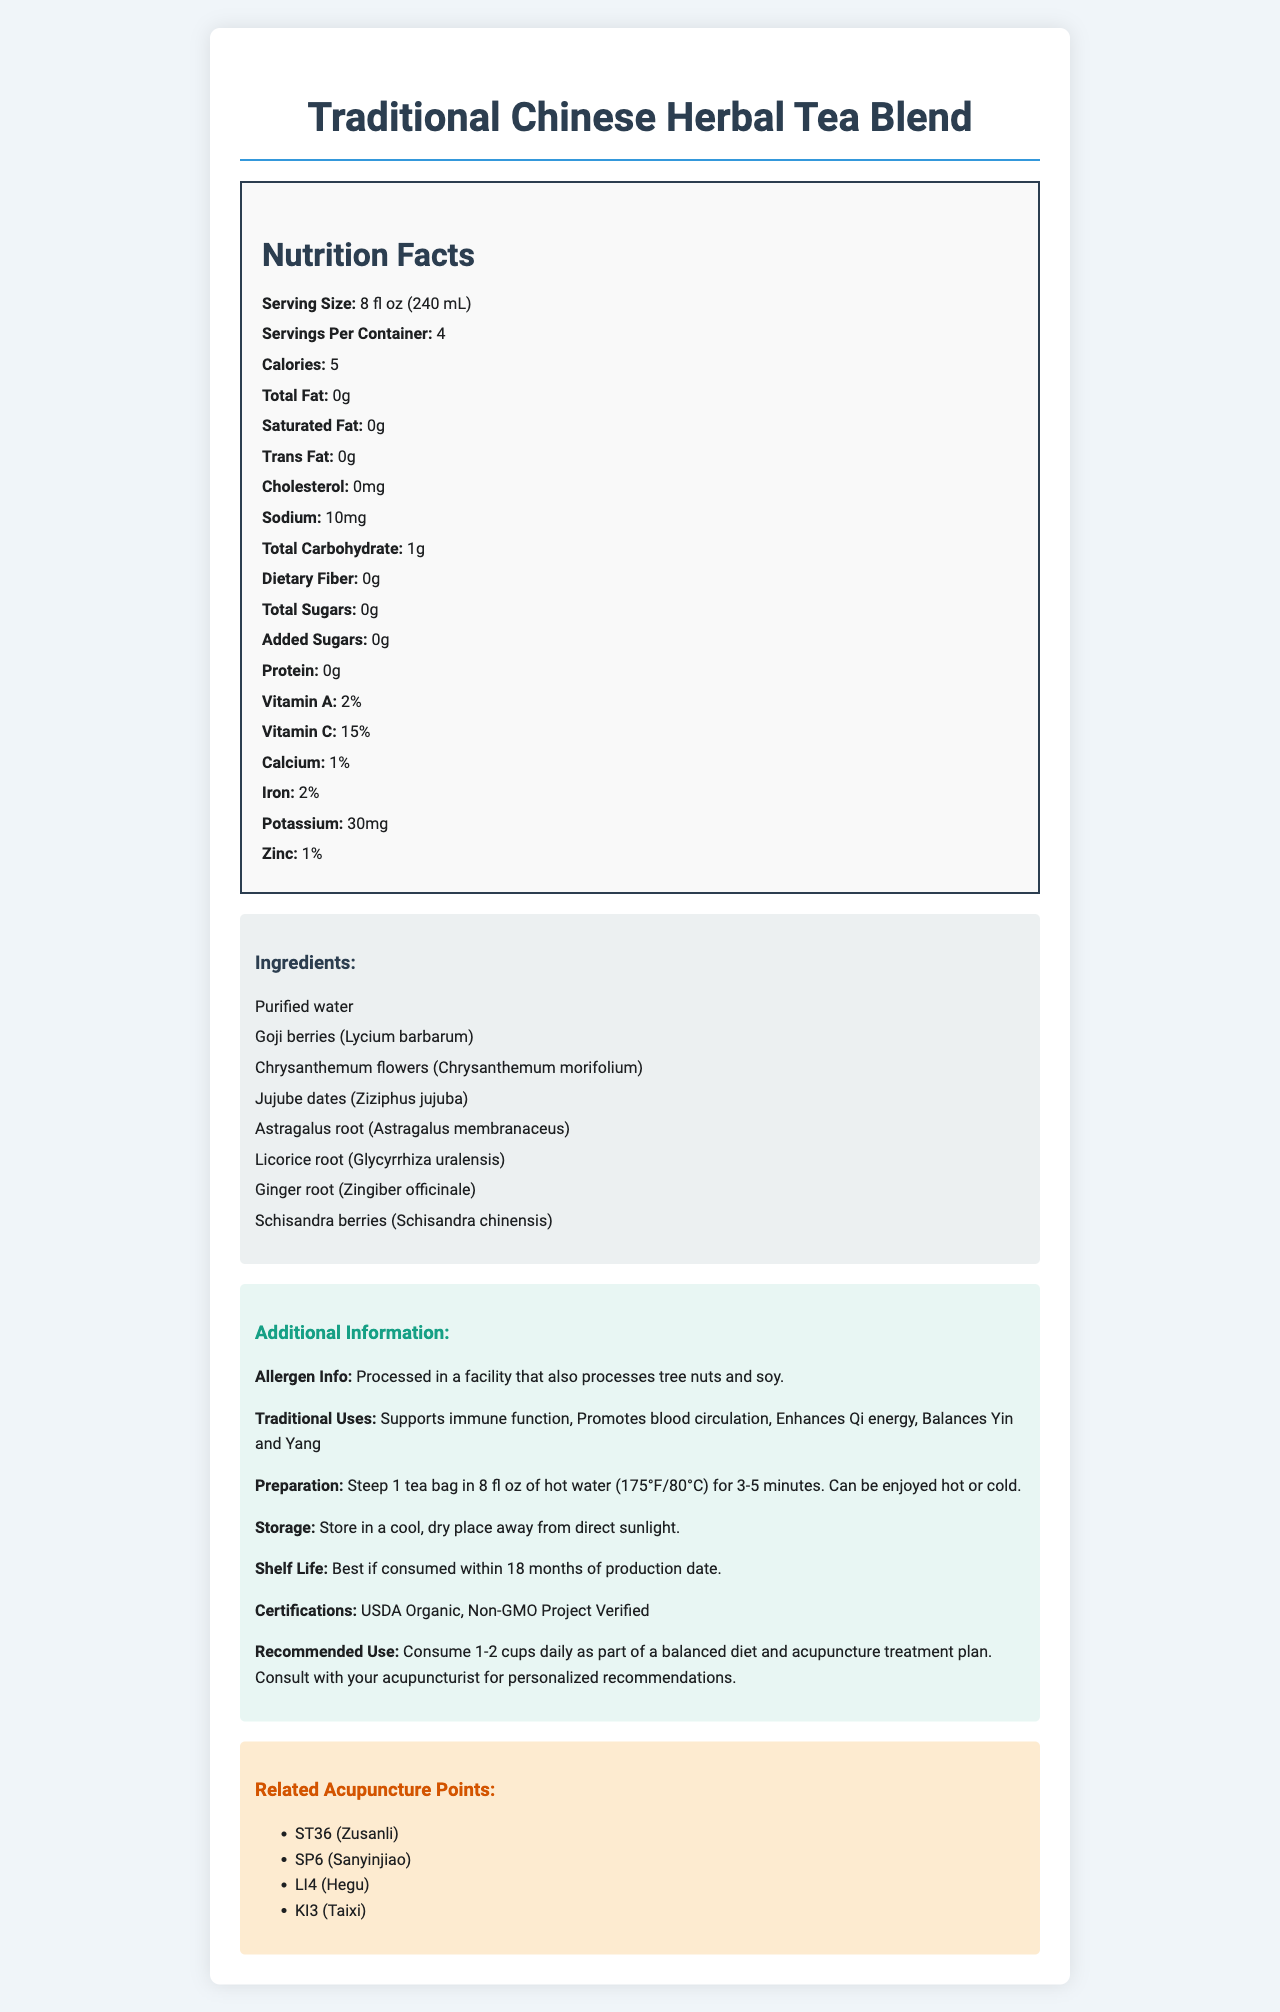What is the serving size of the Traditional Chinese Herbal Tea Blend? The serving size is mentioned at the beginning of the nutrition label under the "Nutrition Facts" section.
Answer: 8 fl oz (240 mL) How many servings are in each container? The number of servings per container is mentioned alongside the serving size in the "Nutrition Facts" section.
Answer: 4 How many calories are in one serving of the tea blend? The calorie content per serving is listed under the "Nutrition Facts" section.
Answer: 5 What are the certifications of this product? The certifications are listed under the "Additional Information" section of the document.
Answer: USDA Organic, Non-GMO Project Verified List three traditional uses of the tea blend. The traditional uses are listed in the "Additional Information" section under "Traditional Uses."
Answer: Supports immune function, Promotes blood circulation, Enhances Qi energy Which ingredient is NOT present in the tea blend? A. Goji berries B. Licorice root C. Ginseng The ingredients list includes Goji berries and Licorice root but does not mention Ginseng.
Answer: C. Ginseng What is the sodium content in one serving? The amount of sodium per serving is listed in the "Nutrition Facts" section.
Answer: 10 mg What is the recommended use for this tea blend? A. Consume 1-2 cups daily B. Consume 3-4 cups daily C. Consume before meals The recommended use is stated in the "Additional Information" section under "Recommended Use."
Answer: A. Consume 1-2 cups daily Does the tea contain any protein? The protein content is listed as 0g in the "Nutrition Facts" section.
Answer: No Does this product contain added sugars? The total added sugars content is listed as 0g in the "Nutrition Facts" section.
Answer: No Summarize the main idea of the document. The document is designed to give a comprehensive overview of the tea blend, highlighting its nutritional values, benefits, and how it aligns with traditional Chinese medicine practices and acupuncture points.
Answer: The document provides detailed nutritional information, ingredient list, traditional uses, preparation instructions, storage guidelines, and benefits of the Traditional Chinese Herbal Tea Blend, along with related acupuncture points and certifications. What percent of the daily value of Vitamin C does one serving provide? The percentage of the daily value for Vitamin C is listed in the "Nutrition Facts" section.
Answer: 15% How should the tea be stored to maintain its quality? The storage instructions are provided in the "Additional Information" section.
Answer: Store in a cool, dry place away from direct sunlight. What is the shelf life of the tea blend? The shelf life information is specified in the "Additional Information" section.
Answer: Best if consumed within 18 months of production date. Which acupuncture point is NOT mentioned in the document? A. ST36 B. SP6 C. KD9 D. LI4 The related acupuncture points listed in the document are ST36, SP6, LI4, and KI3; KD9 is not mentioned.
Answer: C. KD9 Based on the document, is this product processed in a facility that also processes peanuts? The allergen information states it is processed in a facility that processes tree nuts and soy, but there is no mention of peanuts.
Answer: Not enough information 